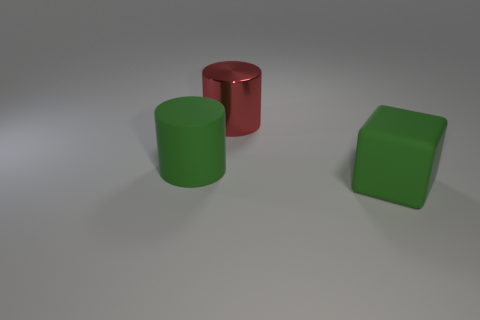Can you describe the shapes and colors visible in the image? Certainly! The image features three geometric shapes. On the left, there is a green cylinder standing upright. In the middle, a red cylinder is lying horizontally. To the right is a green cube. Both green objects share the same hue, indicating a color match, while the red cylinder introduces a contrasting color. These shapes are presented against a neutral gray background, which emphasizes their colors and forms. 